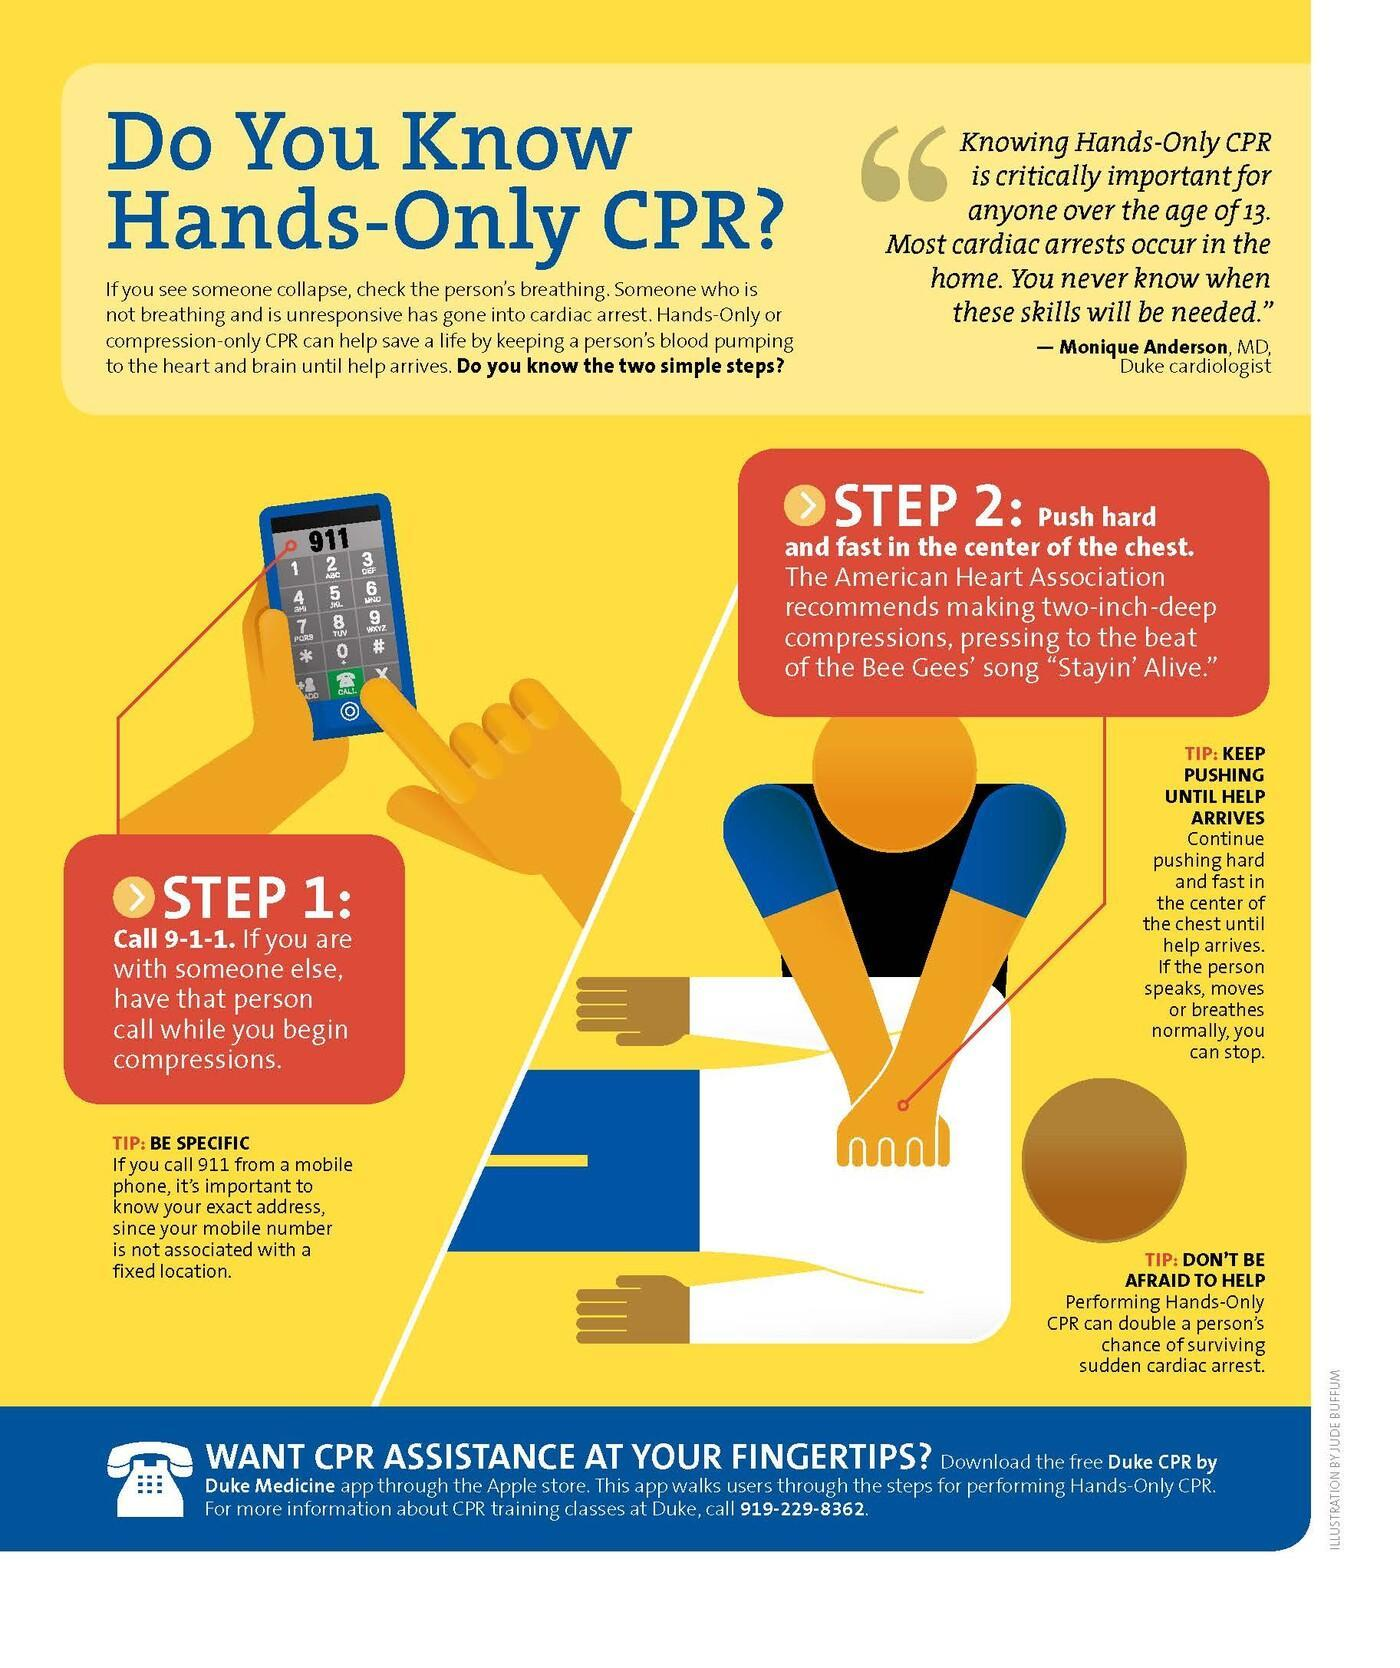What is to be done first when you see someone collapse?
Answer the question with a short phrase. call 9-1-1 What should be done soon after calling for help? Push hard and fast in the center of the chest 